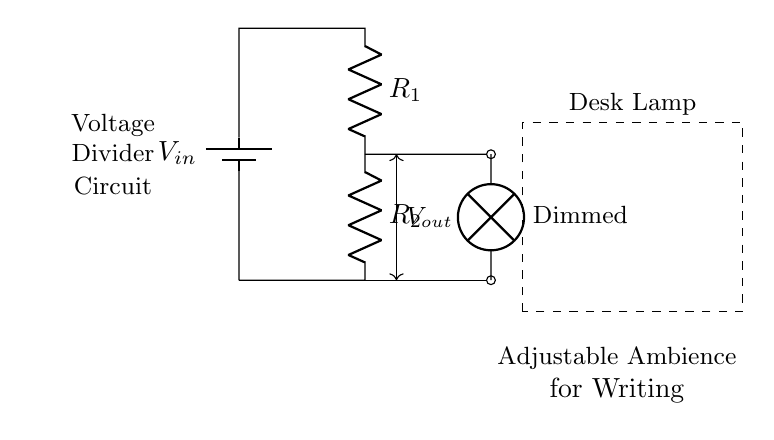What is the input voltage for this circuit? The input voltage is labeled as V-in at the top of the circuit diagram, indicating the source of power for the entire setup.
Answer: V-in What type of circuit is this? The circuit is identified as a voltage divider circuit, which is evident from the arrangement of resistors used to split the voltage across them.
Answer: Voltage divider What does R1 represent? R1 is a resistor in the circuit responsible for dropping a part of the input voltage, and is labeled directly next to the component in the diagram.
Answer: Resistor What is V-out in this circuit? V-out is the voltage across the lamp, which is determined by the voltage division principle of the two resistors in series, connecting from R1 to R2.
Answer: Voltage across the lamp Which component is used to dim the light? The lamp is the component that receives the output voltage and is indicated as "Dimmed," showing it is influenced by the configured voltage divider setup.
Answer: Lamp How many resistors are in this circuit? There are two resistors indicated in the circuit diagram (R1 and R2), both crucial for establishing the voltage division.
Answer: Two What is the primary purpose of this circuit? The primary purpose is to create an adjustable ambience for writing by allowing control over the brightness of the desk lamp.
Answer: Adjustable ambience 